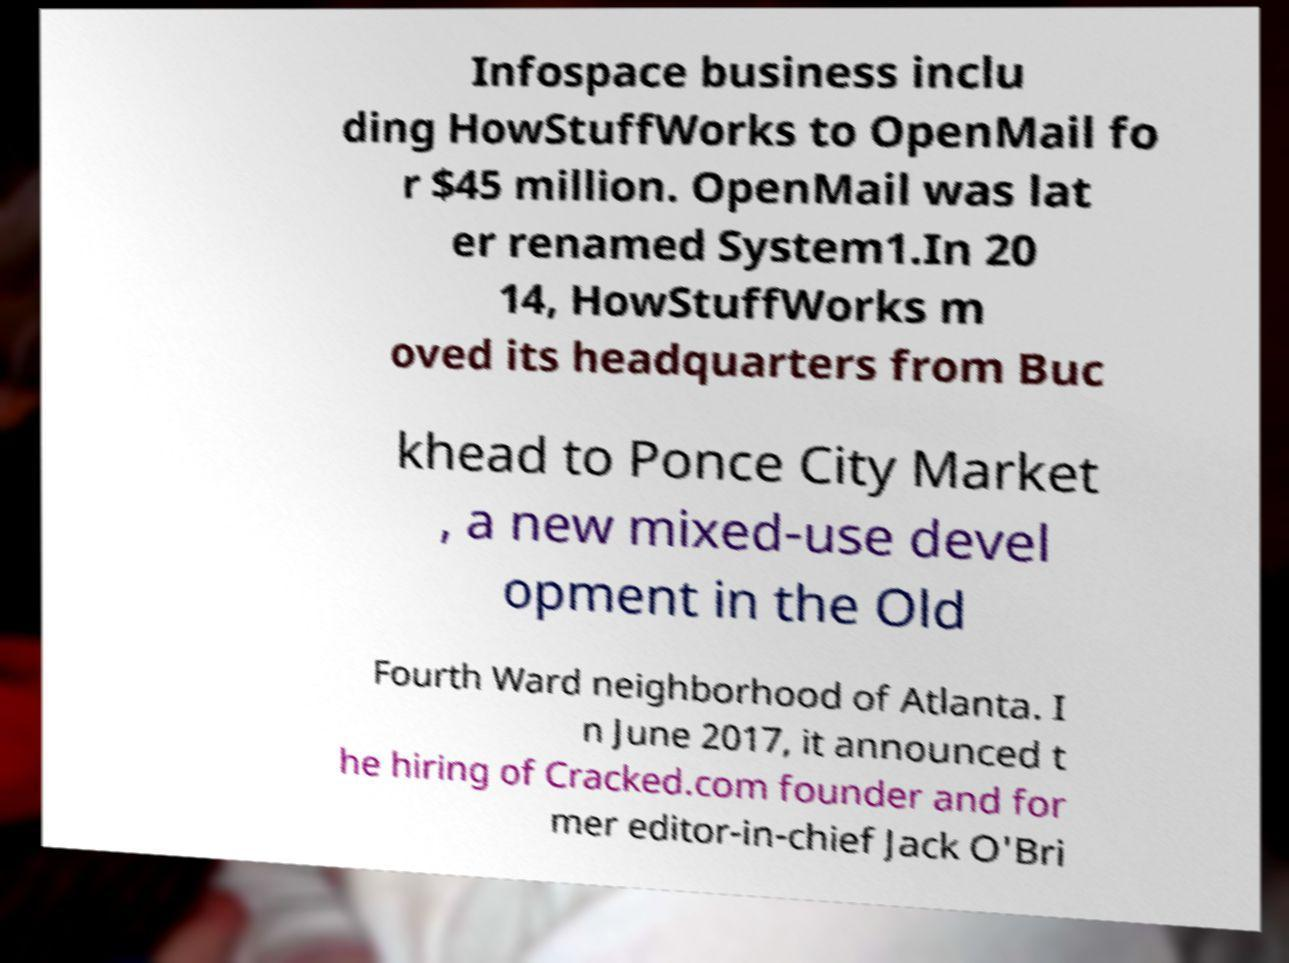I need the written content from this picture converted into text. Can you do that? Infospace business inclu ding HowStuffWorks to OpenMail fo r $45 million. OpenMail was lat er renamed System1.In 20 14, HowStuffWorks m oved its headquarters from Buc khead to Ponce City Market , a new mixed-use devel opment in the Old Fourth Ward neighborhood of Atlanta. I n June 2017, it announced t he hiring of Cracked.com founder and for mer editor-in-chief Jack O'Bri 